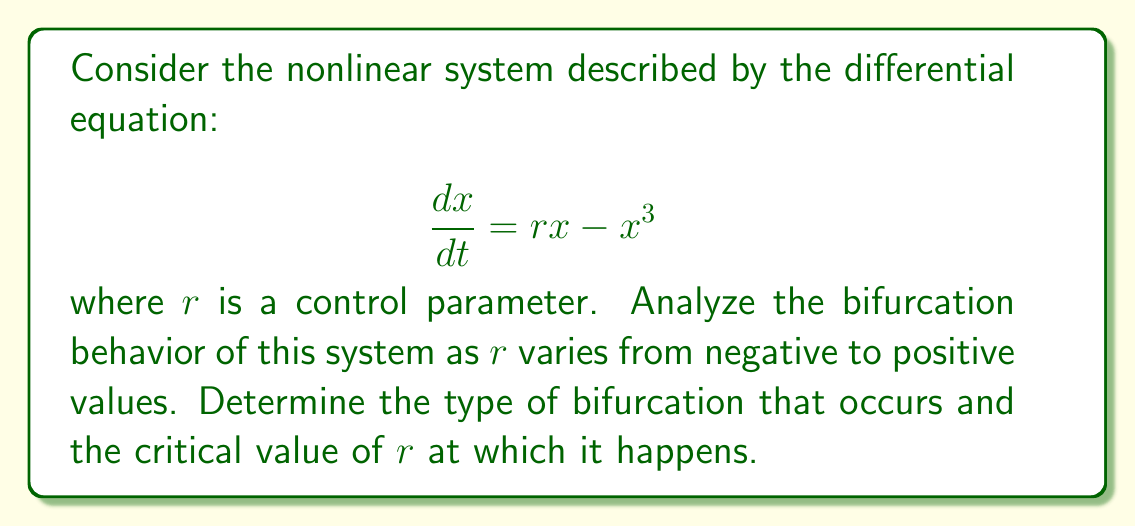Provide a solution to this math problem. 1. First, we need to find the equilibrium points of the system by setting $\frac{dx}{dt} = 0$:

   $$rx - x^3 = 0$$
   $$x(r - x^2) = 0$$

2. This gives us three equilibrium points:
   $x_1 = 0$ (always)
   $x_2 = +\sqrt{r}$ (when $r > 0$)
   $x_3 = -\sqrt{r}$ (when $r > 0$)

3. To analyze stability, we calculate the Jacobian (which in this 1D case is simply the derivative with respect to x):

   $$J = \frac{\partial}{\partial x}(rx - x^3) = r - 3x^2$$

4. Evaluating stability at $x_1 = 0$:
   $J|_{x=0} = r$
   - When $r < 0$, $x_1$ is stable
   - When $r > 0$, $x_1$ is unstable

5. For $x_2$ and $x_3$ (when $r > 0$):
   $J|_{x=\pm\sqrt{r}} = r - 3(\pm\sqrt{r})^2 = r - 3r = -2r < 0$
   So $x_2$ and $x_3$ are stable when they exist ($r > 0$)

6. As $r$ increases from negative to positive:
   - For $r < 0$, only $x_1 = 0$ exists and is stable
   - At $r = 0$, $x_1 = 0$ loses stability
   - For $r > 0$, $x_1 = 0$ is unstable, and two new stable equilibrium points ($\pm\sqrt{r}$) emerge

7. This behavior, where a single stable equilibrium splits into two stable equilibria as a parameter crosses a critical value, is characteristic of a pitchfork bifurcation.

8. The critical value at which this bifurcation occurs is $r = 0$.
Answer: Pitchfork bifurcation at $r = 0$ 